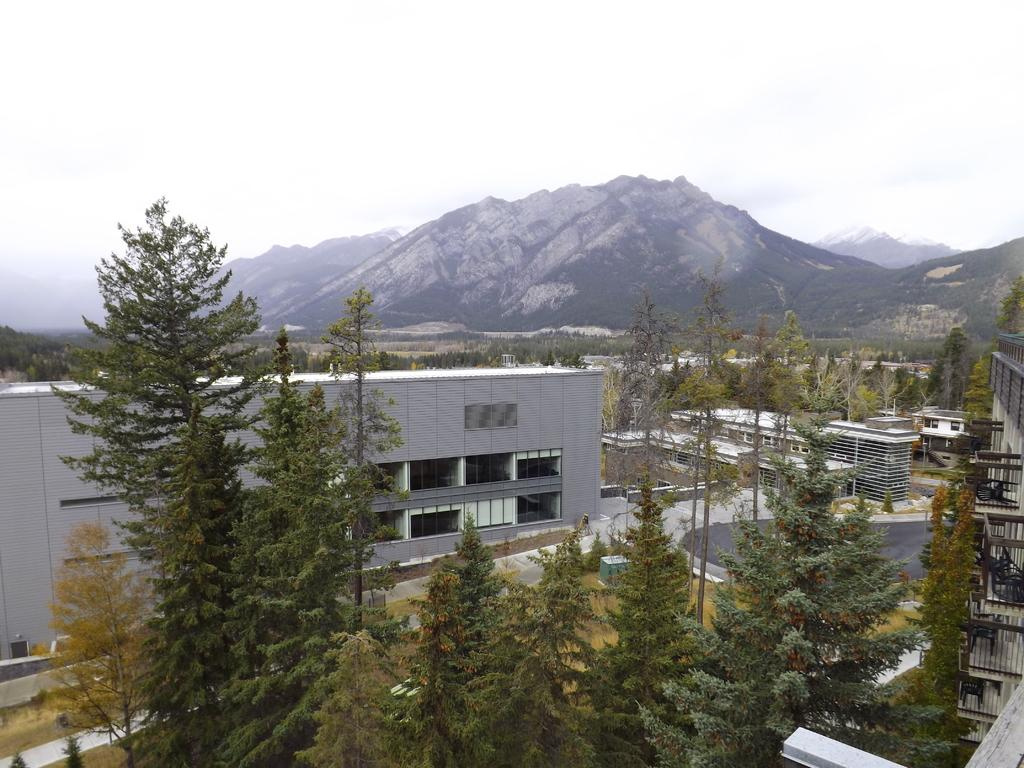What type of vegetation can be seen in the image? There are trees in the image. What type of structures are visible in the image? There are house buildings in the image. Can you describe the background of the image? There are more trees visible in the background. What geographical features can be seen in the distance? There are hills visible in the distance. What part of the natural environment is visible in the image? The sky is visible in the image. What type of wave can be seen crashing on the ground in the image? There is no wave or ground visible in the image; it features trees, house buildings, hills, and the sky. 